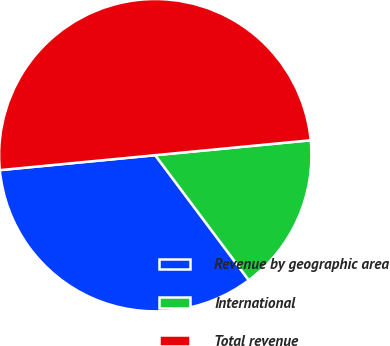Convert chart. <chart><loc_0><loc_0><loc_500><loc_500><pie_chart><fcel>Revenue by geographic area<fcel>International<fcel>Total revenue<nl><fcel>33.7%<fcel>16.3%<fcel>50.0%<nl></chart> 